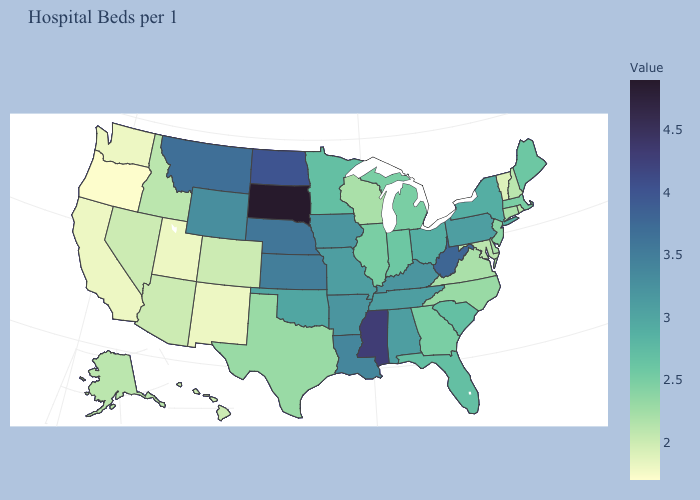Does Missouri have a lower value than South Dakota?
Concise answer only. Yes. Which states have the highest value in the USA?
Quick response, please. South Dakota. Does Michigan have the highest value in the MidWest?
Be succinct. No. 